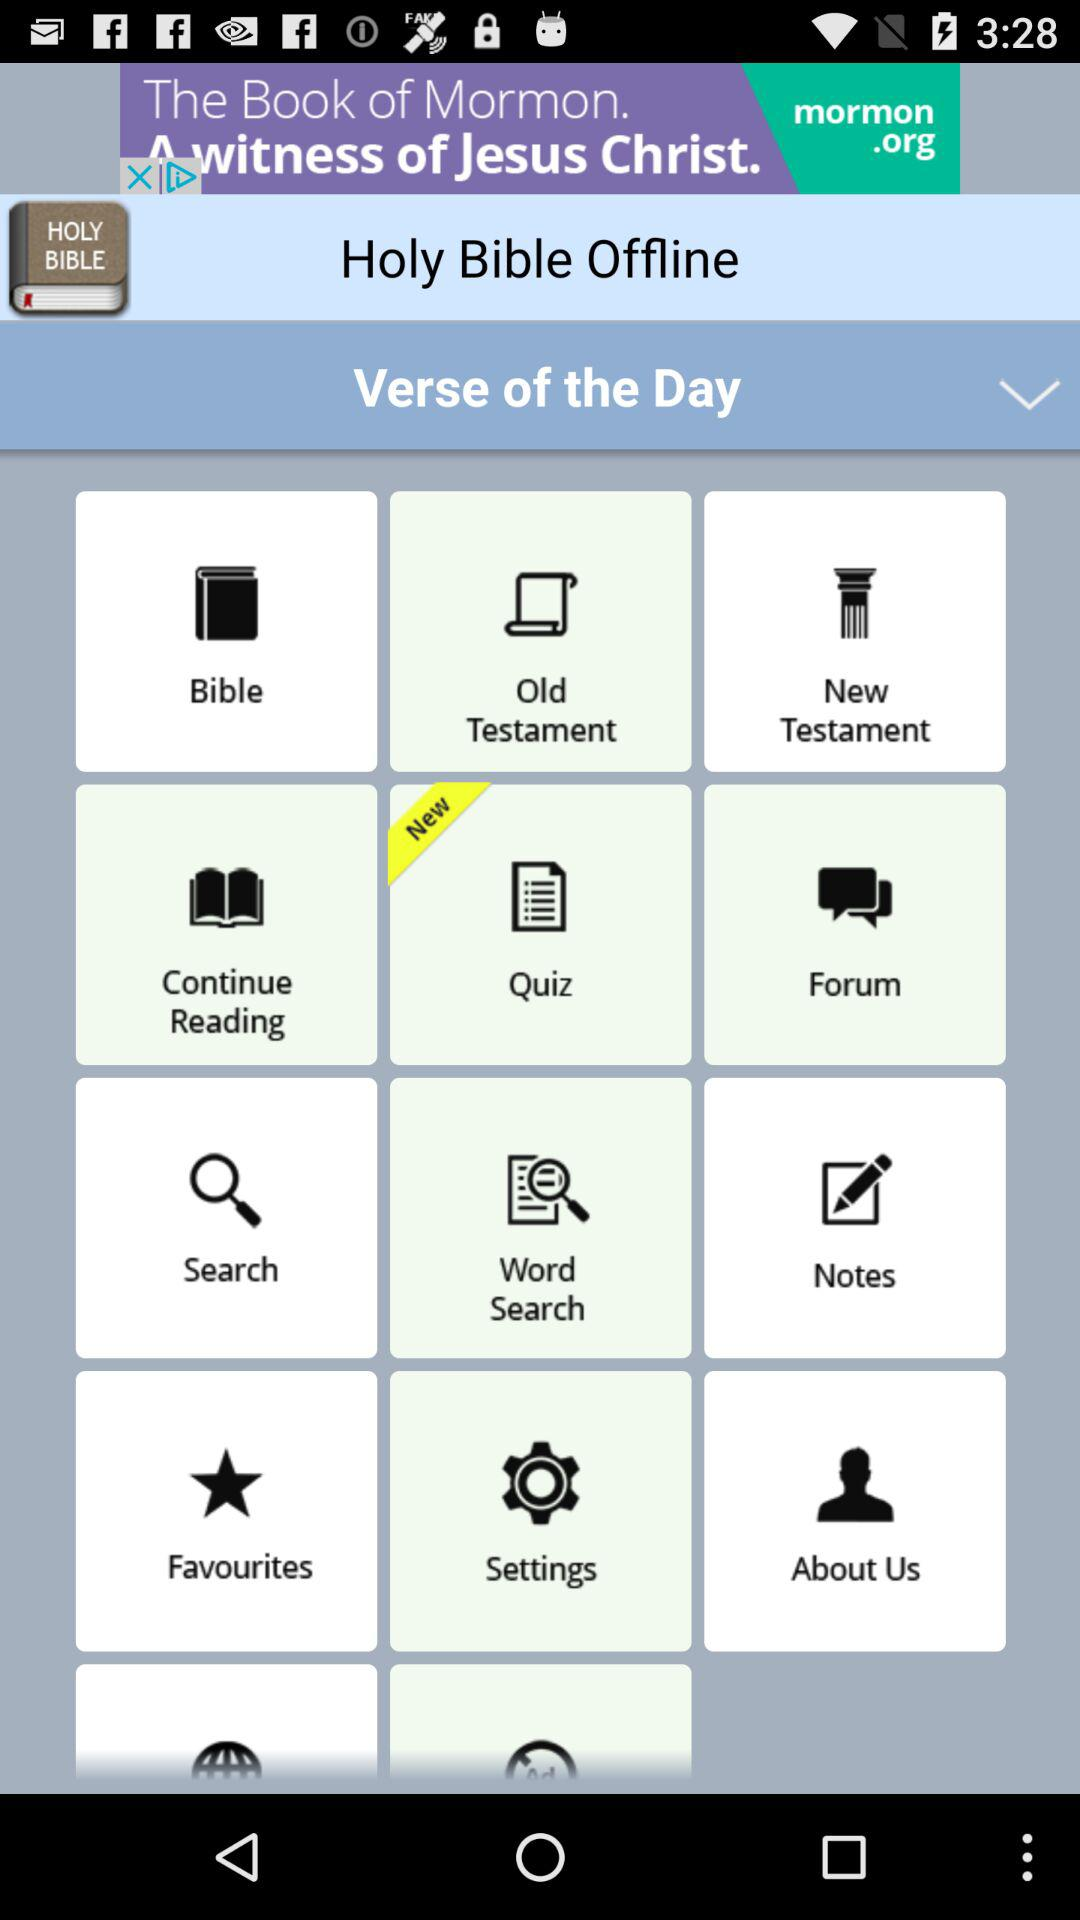What is the app name? The app name is "Holy Bible Offline". 